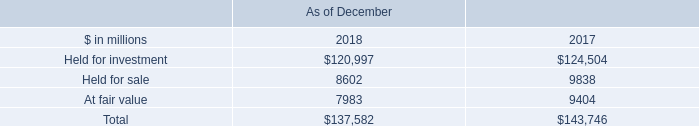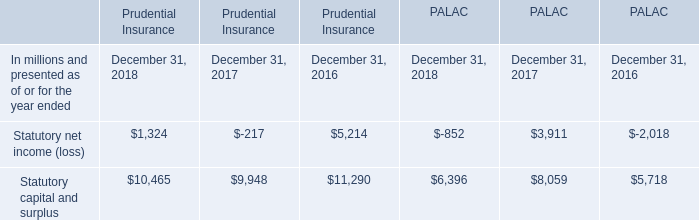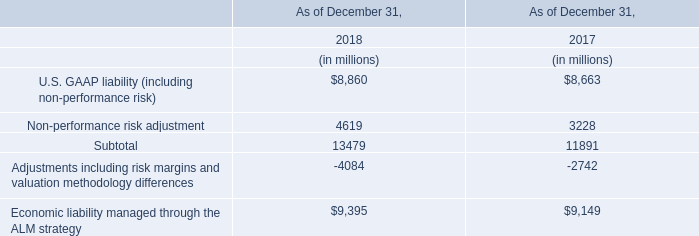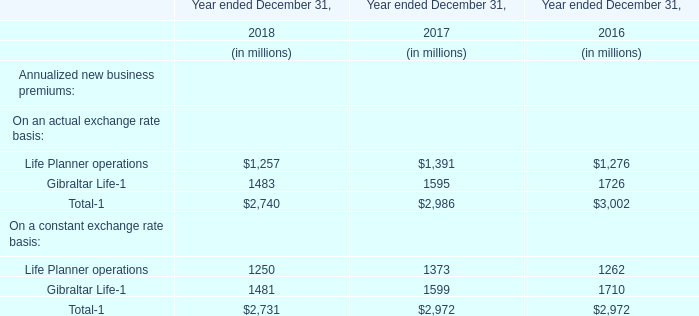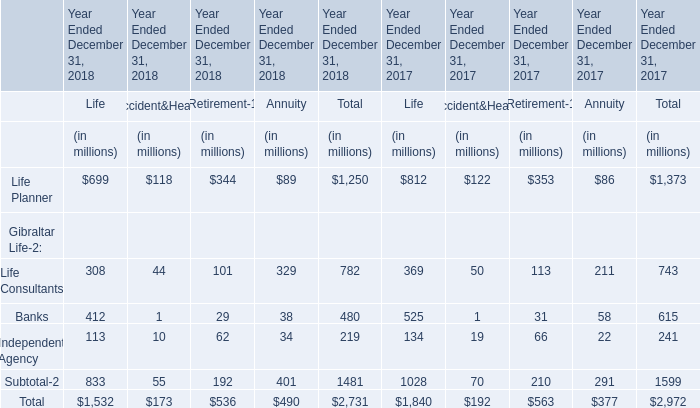What's the sum of Statutory capital and surplus of Prudential Insurance December 31, 2016, and Held for investment of As of December 2017 ? 
Computations: (11290.0 + 124504.0)
Answer: 135794.0. 